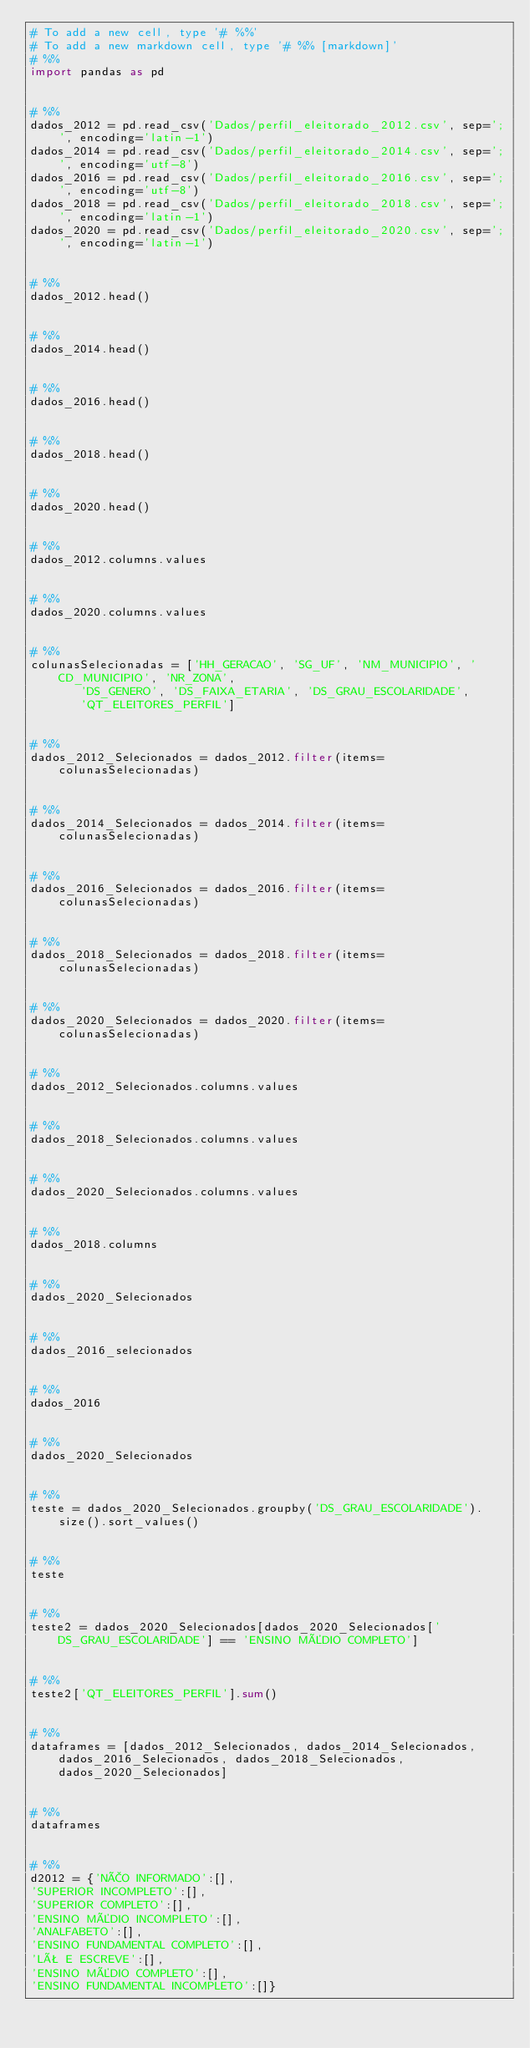<code> <loc_0><loc_0><loc_500><loc_500><_Python_># To add a new cell, type '# %%'
# To add a new markdown cell, type '# %% [markdown]'
# %%
import pandas as pd


# %%
dados_2012 = pd.read_csv('Dados/perfil_eleitorado_2012.csv', sep=';', encoding='latin-1')
dados_2014 = pd.read_csv('Dados/perfil_eleitorado_2014.csv', sep=';', encoding='utf-8')
dados_2016 = pd.read_csv('Dados/perfil_eleitorado_2016.csv', sep=';', encoding='utf-8')
dados_2018 = pd.read_csv('Dados/perfil_eleitorado_2018.csv', sep=';', encoding='latin-1')
dados_2020 = pd.read_csv('Dados/perfil_eleitorado_2020.csv', sep=';', encoding='latin-1')


# %%
dados_2012.head()


# %%
dados_2014.head()


# %%
dados_2016.head()


# %%
dados_2018.head()


# %%
dados_2020.head()


# %%
dados_2012.columns.values


# %%
dados_2020.columns.values


# %%
colunasSelecionadas = ['HH_GERACAO', 'SG_UF', 'NM_MUNICIPIO', 'CD_MUNICIPIO', 'NR_ZONA',
       'DS_GENERO', 'DS_FAIXA_ETARIA', 'DS_GRAU_ESCOLARIDADE',
       'QT_ELEITORES_PERFIL']


# %%
dados_2012_Selecionados = dados_2012.filter(items=colunasSelecionadas)


# %%
dados_2014_Selecionados = dados_2014.filter(items=colunasSelecionadas)


# %%
dados_2016_Selecionados = dados_2016.filter(items=colunasSelecionadas)


# %%
dados_2018_Selecionados = dados_2018.filter(items=colunasSelecionadas)


# %%
dados_2020_Selecionados = dados_2020.filter(items=colunasSelecionadas)


# %%
dados_2012_Selecionados.columns.values


# %%
dados_2018_Selecionados.columns.values


# %%
dados_2020_Selecionados.columns.values


# %%
dados_2018.columns


# %%
dados_2020_Selecionados


# %%
dados_2016_selecionados


# %%
dados_2016


# %%
dados_2020_Selecionados


# %%
teste = dados_2020_Selecionados.groupby('DS_GRAU_ESCOLARIDADE').size().sort_values()


# %%
teste


# %%
teste2 = dados_2020_Selecionados[dados_2020_Selecionados['DS_GRAU_ESCOLARIDADE'] == 'ENSINO MÉDIO COMPLETO']


# %%
teste2['QT_ELEITORES_PERFIL'].sum()


# %%
dataframes = [dados_2012_Selecionados, dados_2014_Selecionados, dados_2016_Selecionados, dados_2018_Selecionados, dados_2020_Selecionados]


# %%
dataframes


# %%
d2012 = {'NÃO INFORMADO':[],
'SUPERIOR INCOMPLETO':[],
'SUPERIOR COMPLETO':[],
'ENSINO MÉDIO INCOMPLETO':[],
'ANALFABETO':[],
'ENSINO FUNDAMENTAL COMPLETO':[],
'LÊ E ESCREVE':[],
'ENSINO MÉDIO COMPLETO':[],
'ENSINO FUNDAMENTAL INCOMPLETO':[]}


</code> 